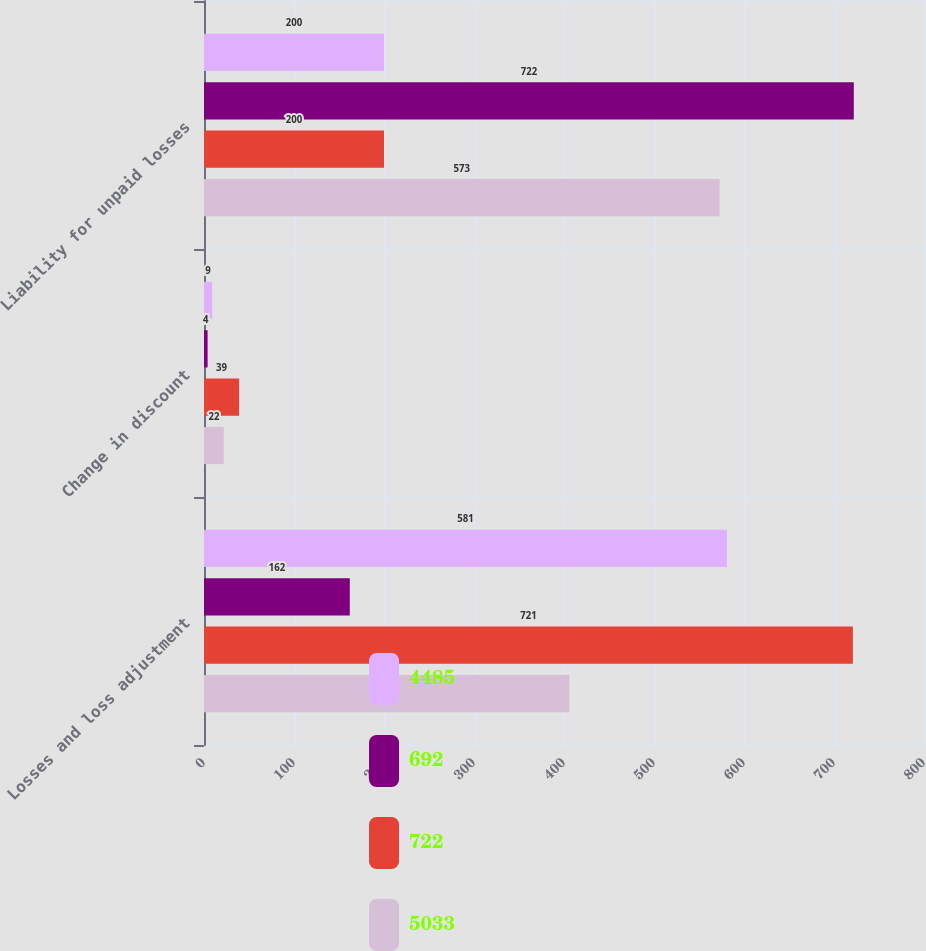<chart> <loc_0><loc_0><loc_500><loc_500><stacked_bar_chart><ecel><fcel>Losses and loss adjustment<fcel>Change in discount<fcel>Liability for unpaid losses<nl><fcel>4485<fcel>581<fcel>9<fcel>200<nl><fcel>692<fcel>162<fcel>4<fcel>722<nl><fcel>722<fcel>721<fcel>39<fcel>200<nl><fcel>5033<fcel>406<fcel>22<fcel>573<nl></chart> 